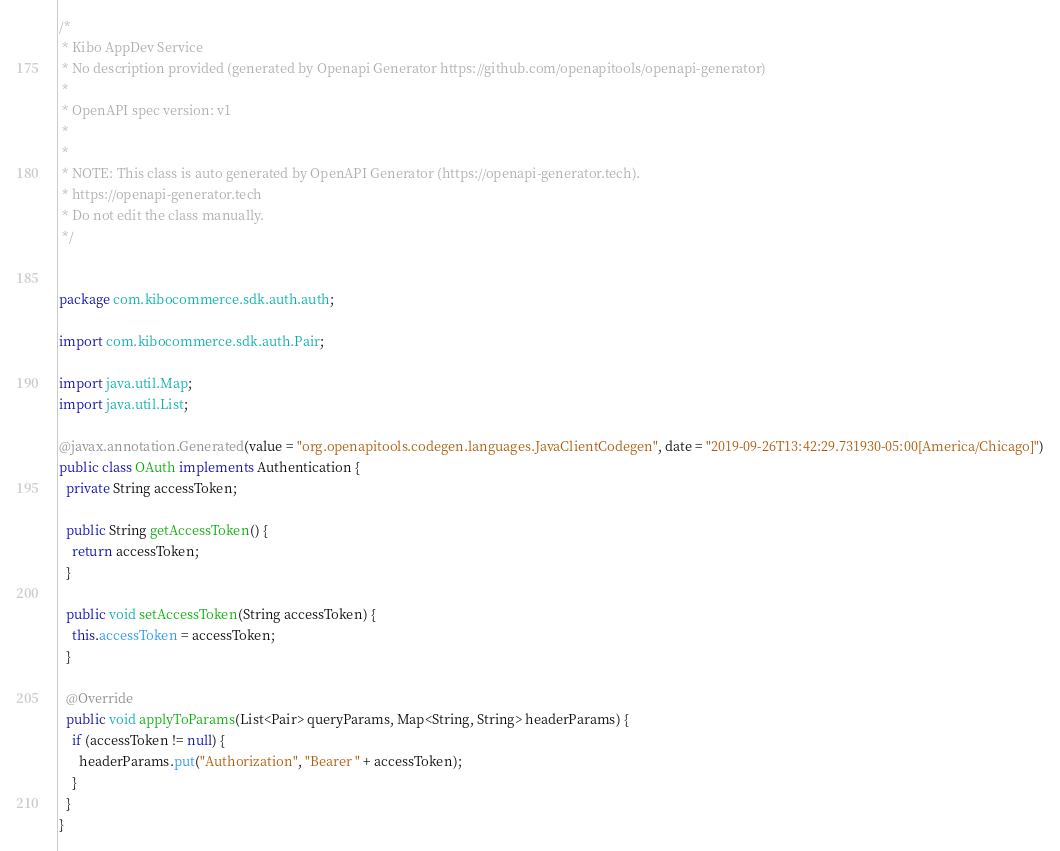Convert code to text. <code><loc_0><loc_0><loc_500><loc_500><_Java_>/*
 * Kibo AppDev Service
 * No description provided (generated by Openapi Generator https://github.com/openapitools/openapi-generator)
 *
 * OpenAPI spec version: v1
 * 
 *
 * NOTE: This class is auto generated by OpenAPI Generator (https://openapi-generator.tech).
 * https://openapi-generator.tech
 * Do not edit the class manually.
 */


package com.kibocommerce.sdk.auth.auth;

import com.kibocommerce.sdk.auth.Pair;

import java.util.Map;
import java.util.List;

@javax.annotation.Generated(value = "org.openapitools.codegen.languages.JavaClientCodegen", date = "2019-09-26T13:42:29.731930-05:00[America/Chicago]")
public class OAuth implements Authentication {
  private String accessToken;

  public String getAccessToken() {
    return accessToken;
  }

  public void setAccessToken(String accessToken) {
    this.accessToken = accessToken;
  }

  @Override
  public void applyToParams(List<Pair> queryParams, Map<String, String> headerParams) {
    if (accessToken != null) {
      headerParams.put("Authorization", "Bearer " + accessToken);
    }
  }
}
</code> 